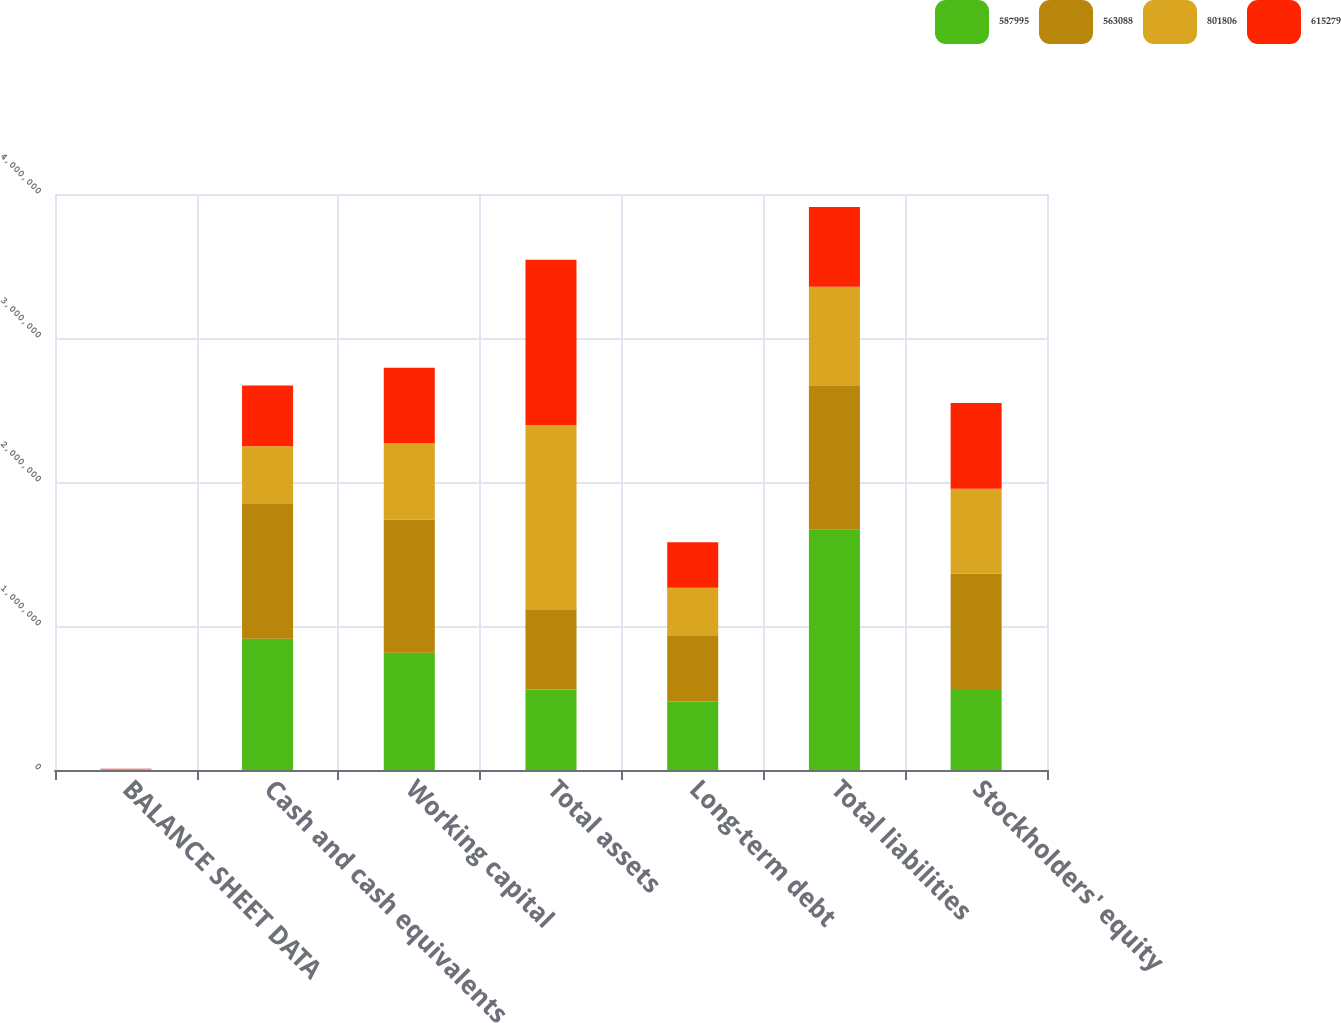Convert chart to OTSL. <chart><loc_0><loc_0><loc_500><loc_500><stacked_bar_chart><ecel><fcel>BALANCE SHEET DATA<fcel>Cash and cash equivalents<fcel>Working capital<fcel>Total assets<fcel>Long-term debt<fcel>Total liabilities<fcel>Stockholders' equity<nl><fcel>587995<fcel>2015<fcel>911120<fcel>815048<fcel>558394<fcel>476057<fcel>1.66801e+06<fcel>563088<nl><fcel>563088<fcel>2014<fcel>935400<fcel>924620<fcel>558394<fcel>454031<fcel>997824<fcel>801806<nl><fcel>801806<fcel>2013<fcel>402502<fcel>529153<fcel>1.27784e+06<fcel>335202<fcel>689844<fcel>587995<nl><fcel>615279<fcel>2012<fcel>420279<fcel>524892<fcel>1.14943e+06<fcel>316340<fcel>553700<fcel>595727<nl></chart> 